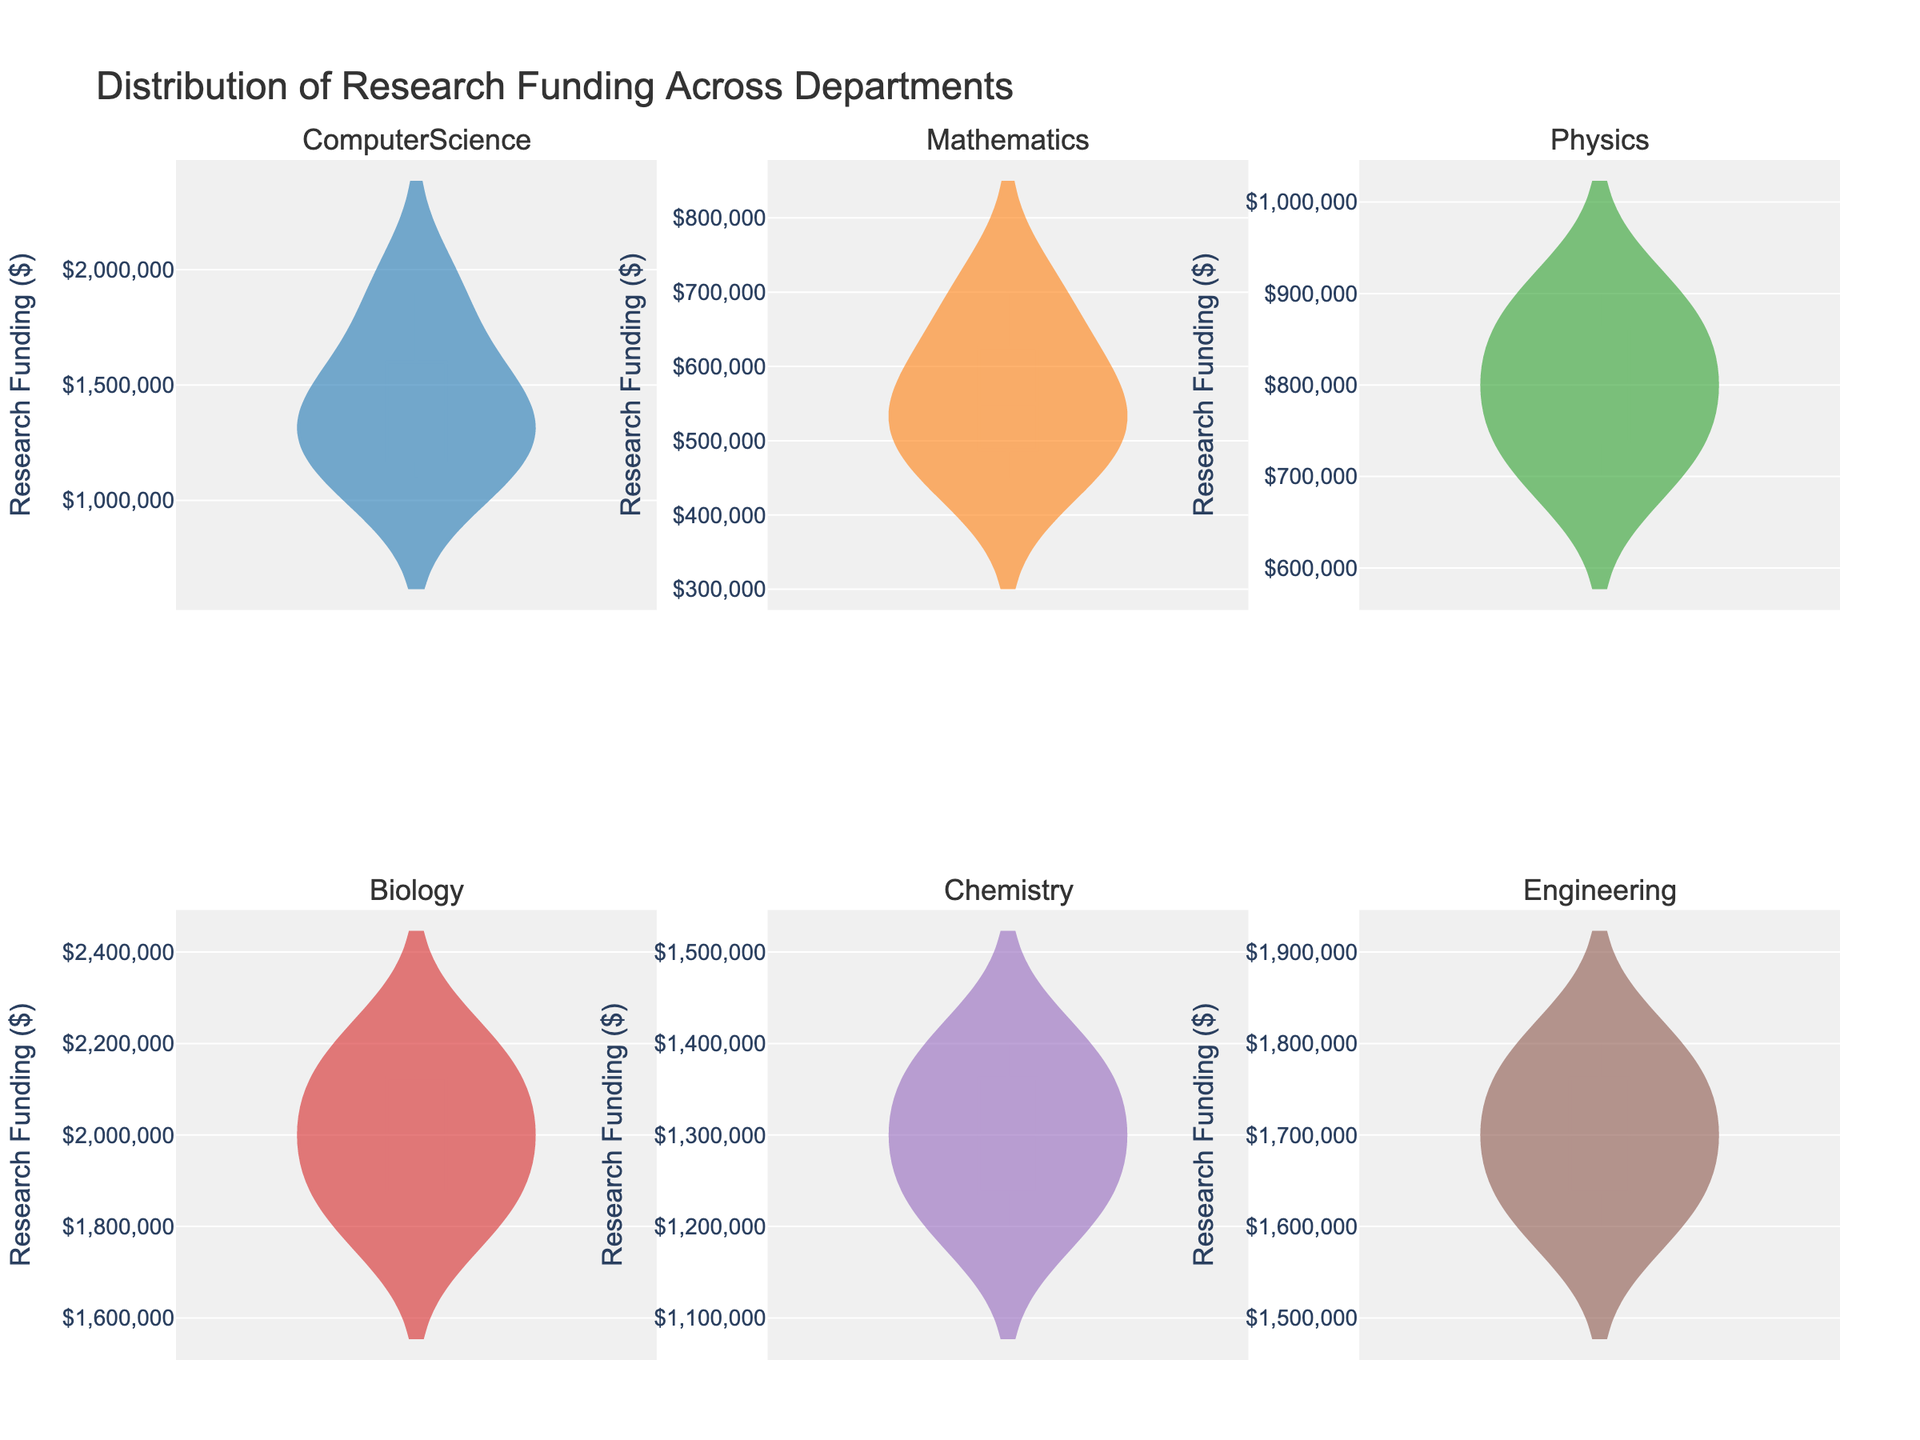What is the title of the figure? The title is centrally located at the top of the figure and is clearly visible. It states the subject of the figure.
Answer: Distribution of Research Funding Across Departments How many departments are displayed in the figure? The subplot titles indicate each department, and counting all the unique titles will give the number of departments.
Answer: 6 Which department has the highest maximum research funding? By examining the upper bounds of the violin plots, we can see which department's plot extends the furthest upward.
Answer: Biology What is the average research funding amount for the Mathematics department? To calculate the average, sum all the values for the Mathematics department and divide by the number of values: (500000 + 450000 + 600000 + 700000 + 550000) / 5.
Answer: 560000 Which department has the widest spread of research funding? The spread can be determined by the length of the violin plot from the minimum to the maximum, indicating variability.
Answer: Biology How does the median research funding for the Physics department compare to the median for the Chemistry department? Medians are represented by the white dot within the violin plots. Comparing their vertical positions in their respective plots will show which is higher.
Answer: Chemistry has a higher median What can be said about the distribution of research funding in the Computer Science department? The shape of the violin plot indicates data distribution. A wider section means more data points are concentrated in that funding range.
Answer: The distribution is somewhat uniform with no significant peaks Which department shows the least variability in research funding amounts? The department with the shortest vertical range in its violin plot has the least variability.
Answer: Mathematics Is there any department where all funding amounts are less than $1,000,000? By examining the upper bound of the violin plots' y-axis, we can determine if any department's maximum is below $1,000,000.
Answer: Mathematics 